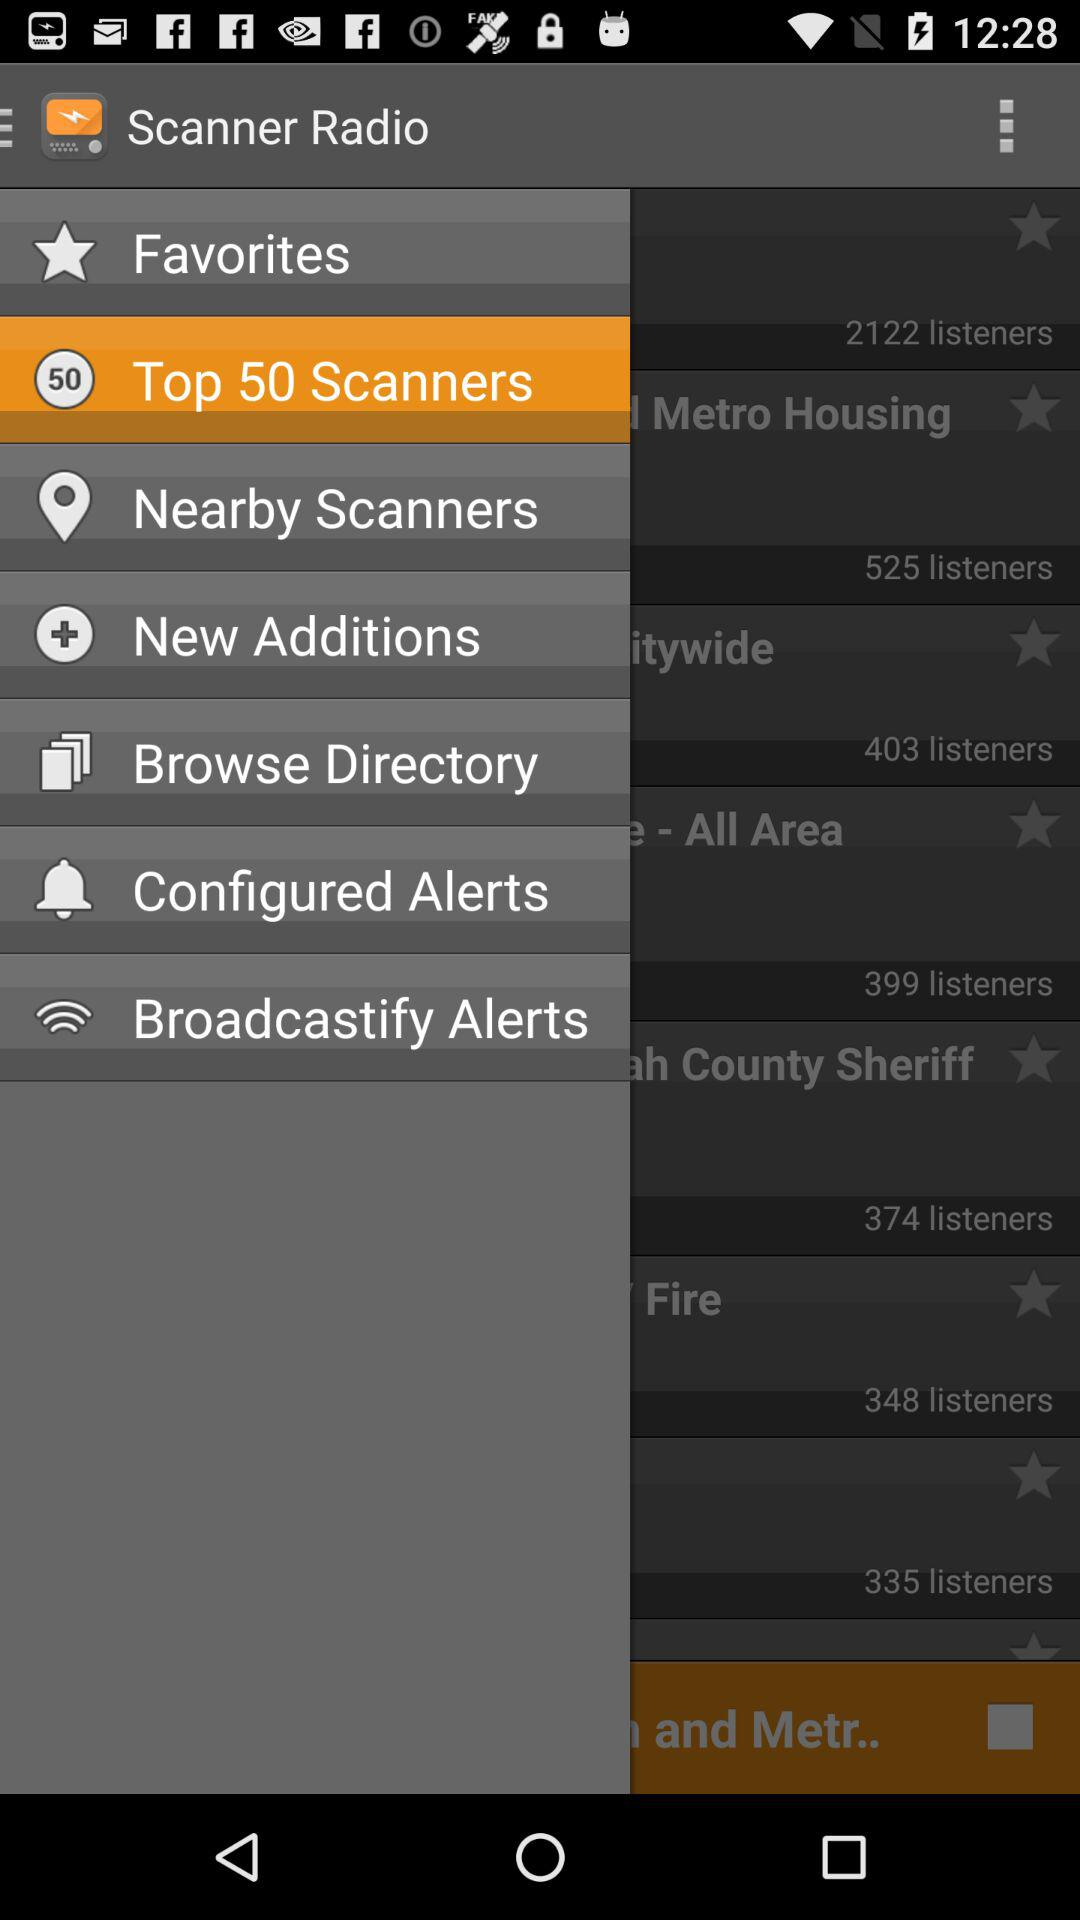How many notifications are there in "New Additions"?
When the provided information is insufficient, respond with <no answer>. <no answer> 